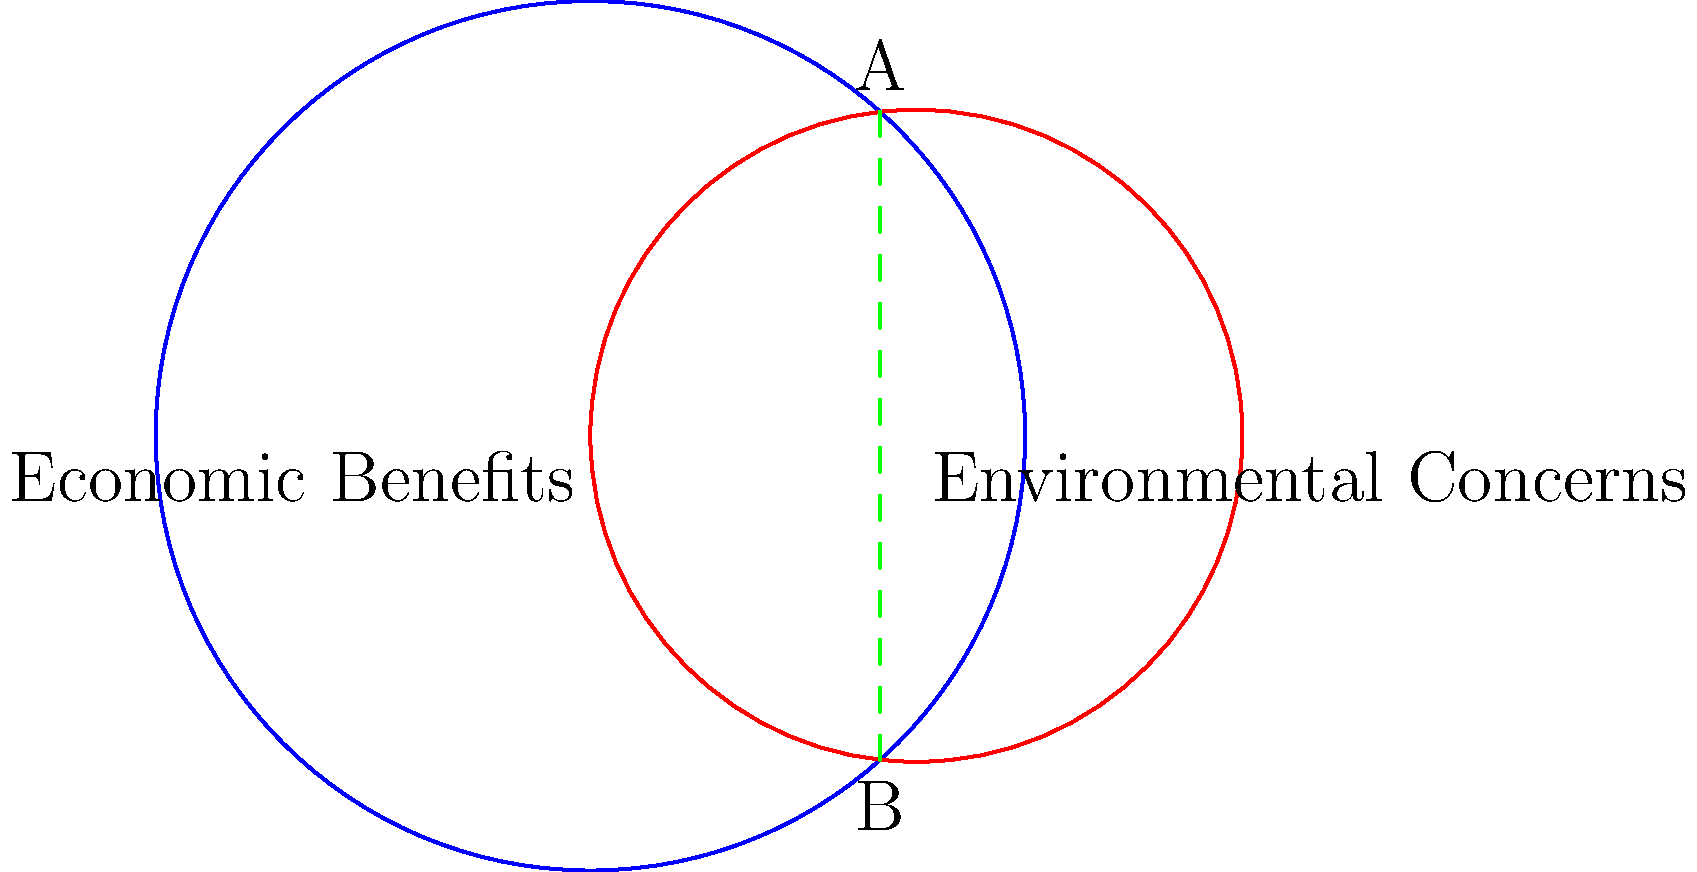Two circles represent the overlap between economic benefits (blue circle) and environmental concerns (red circle) of fracking. The blue circle has a radius of 4 units and is centered at (0,0), while the red circle has a radius of 3 units and is centered at (3,0). Calculate the area of the region where the two circles overlap (shaded green). Round your answer to two decimal places. To find the area of overlap between two intersecting circles, we can use the following steps:

1) First, we need to find the distance between the centers of the circles:
   $d = 3$ (given in the question)

2) Calculate the angles $\theta_1$ and $\theta_2$ using the law of cosines:

   $\cos(\theta_1/2) = \frac{r_1^2 + d^2 - r_2^2}{2r_1d} = \frac{4^2 + 3^2 - 3^2}{2 \cdot 4 \cdot 3} = \frac{19}{24}$
   $\theta_1 = 2 \arccos(\frac{19}{24}) = 1.2490$ radians

   $\cos(\theta_2/2) = \frac{r_2^2 + d^2 - r_1^2}{2r_2d} = \frac{3^2 + 3^2 - 4^2}{2 \cdot 3 \cdot 3} = \frac{1}{6}$
   $\theta_2 = 2 \arccos(\frac{1}{6}) = 2.7307$ radians

3) Calculate the areas of the circular sectors:
   $A_1 = \frac{1}{2}r_1^2\theta_1 = \frac{1}{2} \cdot 4^2 \cdot 1.2490 = 9.9920$
   $A_2 = \frac{1}{2}r_2^2\theta_2 = \frac{1}{2} \cdot 3^2 \cdot 2.7307 = 12.2882$

4) Calculate the areas of the triangles:
   $A_{triangle1} = \frac{1}{2}r_1^2\sin(\theta_1) = \frac{1}{2} \cdot 4^2 \cdot \sin(1.2490) = 7.4940$
   $A_{triangle2} = \frac{1}{2}r_2^2\sin(\theta_2) = \frac{1}{2} \cdot 3^2 \cdot \sin(2.7307) = 4.1471$

5) The area of overlap is the sum of the circular sectors minus the sum of the triangles:
   $A_{overlap} = (A_1 + A_2) - (A_{triangle1} + A_{triangle2})$
   $A_{overlap} = (9.9920 + 12.2882) - (7.4940 + 4.1471) = 10.6391$

6) Rounding to two decimal places: 10.64 square units
Answer: 10.64 square units 